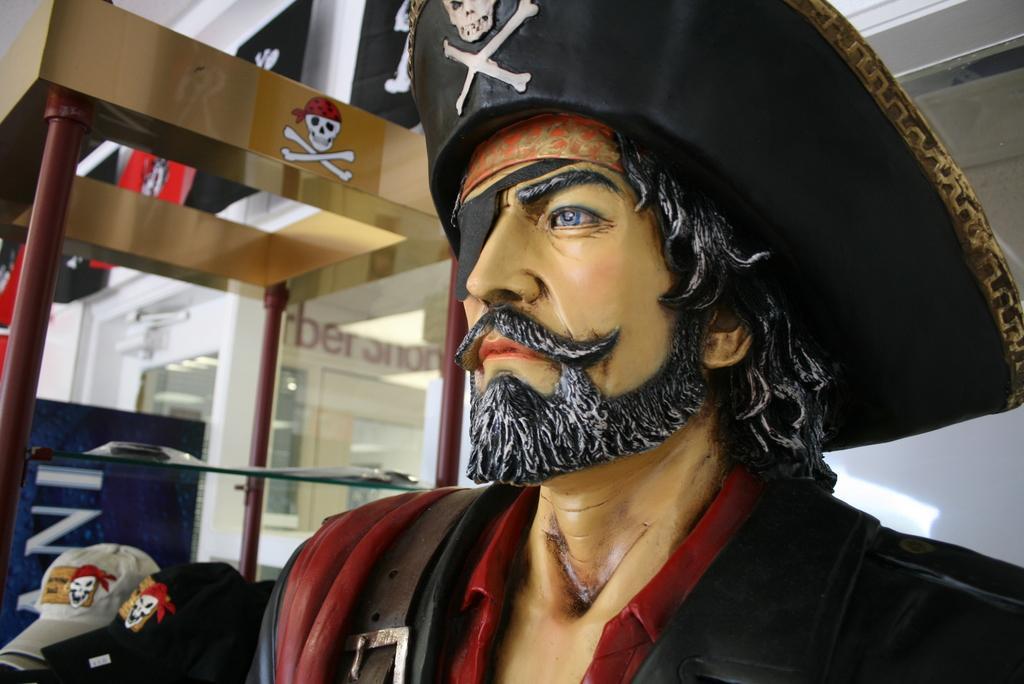Could you give a brief overview of what you see in this image? On the right side, there is a statue of a person, wearing a cap. In the background, there are caps arranged, there is a building which is having glass windows, glass door and hoardings on the wall. 